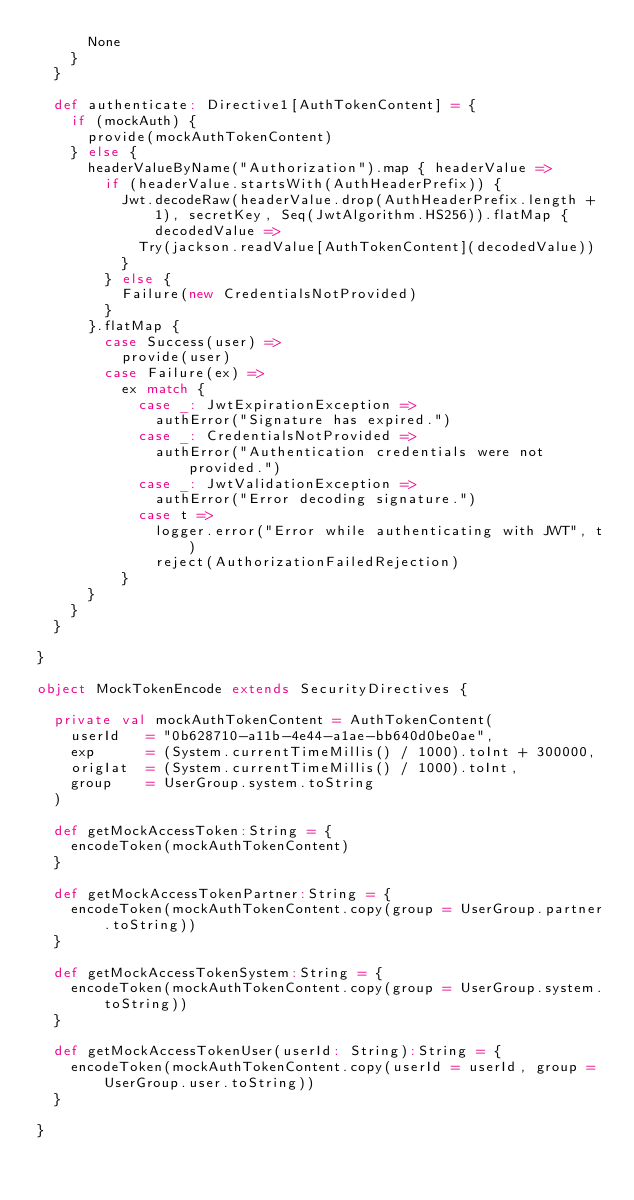<code> <loc_0><loc_0><loc_500><loc_500><_Scala_>      None
    }
  }

  def authenticate: Directive1[AuthTokenContent] = {
    if (mockAuth) {
      provide(mockAuthTokenContent)
    } else {
      headerValueByName("Authorization").map { headerValue =>
        if (headerValue.startsWith(AuthHeaderPrefix)) {
          Jwt.decodeRaw(headerValue.drop(AuthHeaderPrefix.length + 1), secretKey, Seq(JwtAlgorithm.HS256)).flatMap { decodedValue =>
            Try(jackson.readValue[AuthTokenContent](decodedValue))
          }
        } else {
          Failure(new CredentialsNotProvided)
        }
      }.flatMap {
        case Success(user) =>
          provide(user)
        case Failure(ex) =>
          ex match {
            case _: JwtExpirationException =>
              authError("Signature has expired.")
            case _: CredentialsNotProvided =>
              authError("Authentication credentials were not provided.")
            case _: JwtValidationException =>
              authError("Error decoding signature.")
            case t =>
              logger.error("Error while authenticating with JWT", t)
              reject(AuthorizationFailedRejection)
          }
      }
    }
  }

}

object MockTokenEncode extends SecurityDirectives {

  private val mockAuthTokenContent = AuthTokenContent(
    userId   = "0b628710-a11b-4e44-a1ae-bb640d0be0ae",
    exp      = (System.currentTimeMillis() / 1000).toInt + 300000,
    origIat  = (System.currentTimeMillis() / 1000).toInt,
    group    = UserGroup.system.toString
  )

  def getMockAccessToken:String = {
    encodeToken(mockAuthTokenContent)
  }

  def getMockAccessTokenPartner:String = {
    encodeToken(mockAuthTokenContent.copy(group = UserGroup.partner.toString))
  }

  def getMockAccessTokenSystem:String = {
    encodeToken(mockAuthTokenContent.copy(group = UserGroup.system.toString))
  }

  def getMockAccessTokenUser(userId: String):String = {
    encodeToken(mockAuthTokenContent.copy(userId = userId, group = UserGroup.user.toString))
  }

}</code> 